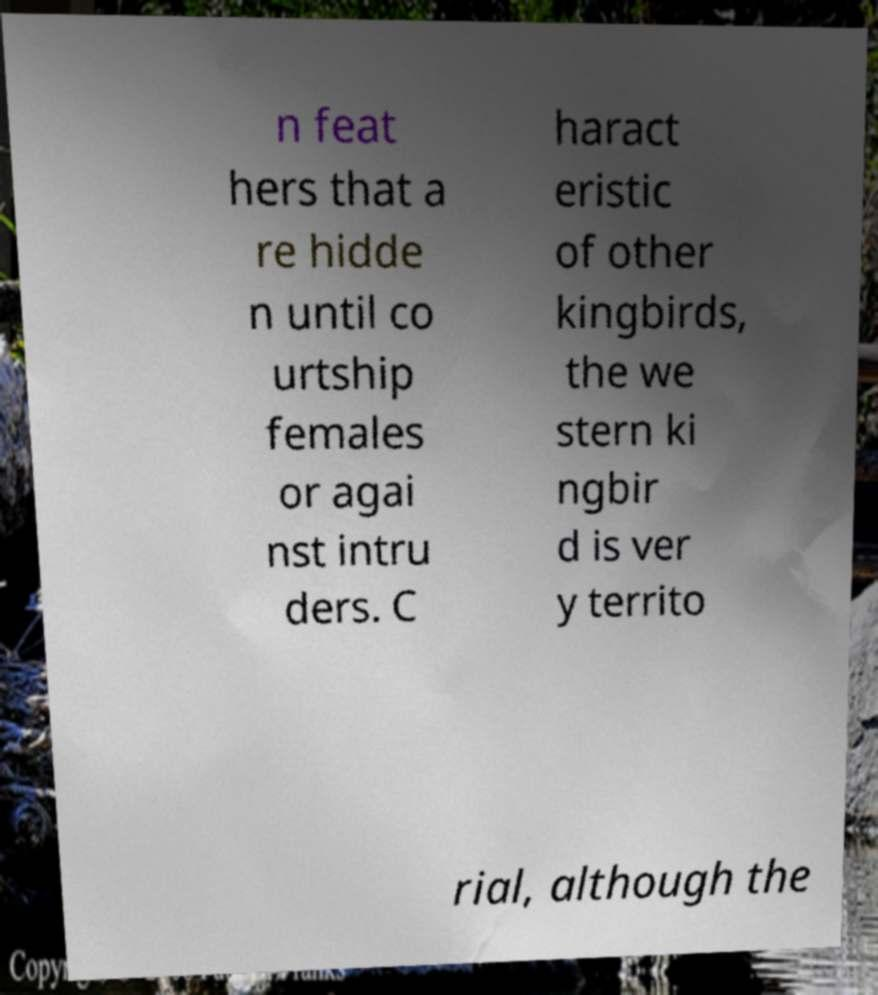There's text embedded in this image that I need extracted. Can you transcribe it verbatim? n feat hers that a re hidde n until co urtship females or agai nst intru ders. C haract eristic of other kingbirds, the we stern ki ngbir d is ver y territo rial, although the 